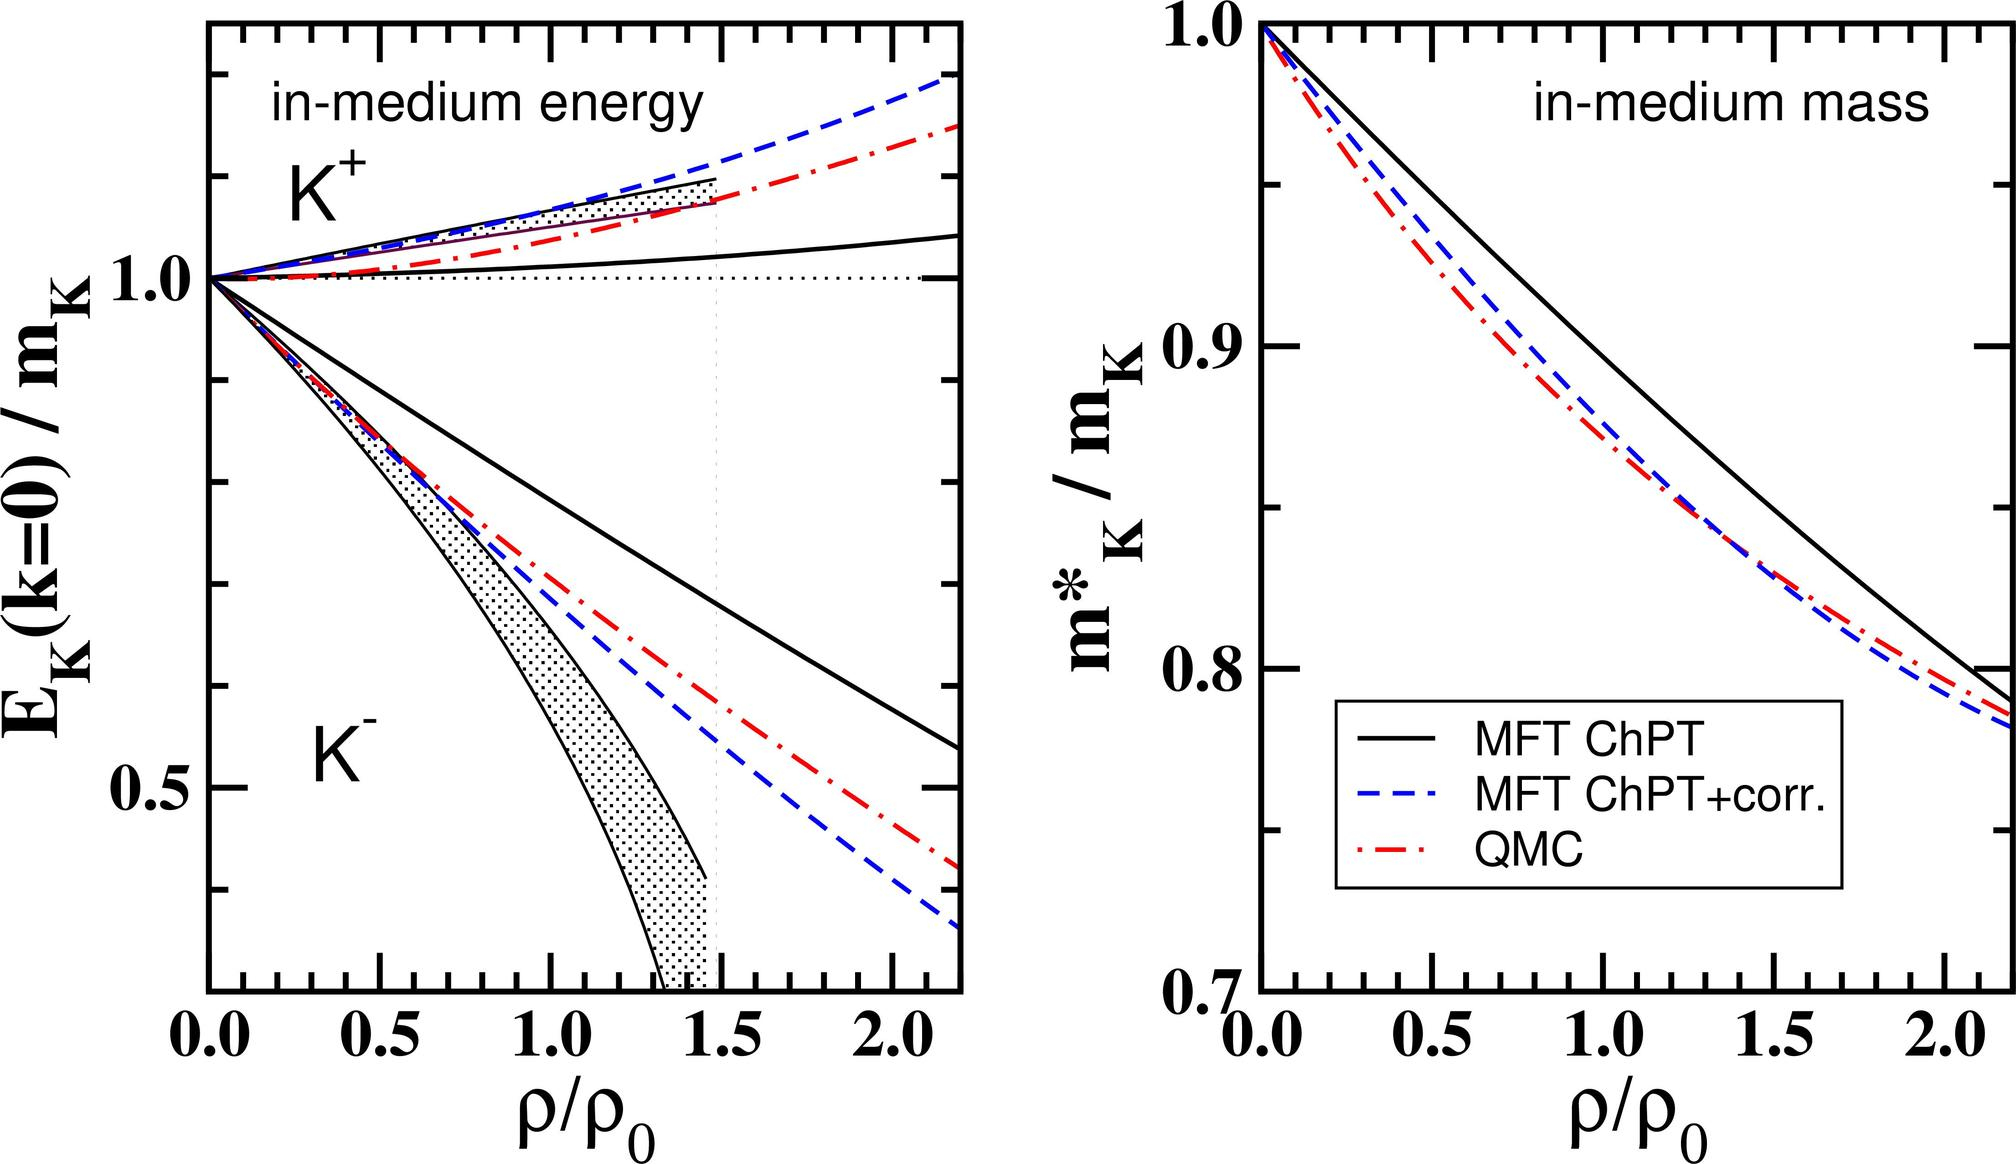What implications might these predictions have for understanding neutron star interiors? Theoretical predictions about the mass of \( K^+ \) mesons in different nuclear densities, as illustrated in the graph, are crucial for understanding the properties of neutron star interiors. Neutron stars, having extremely high nuclear density, can be better modeled with these predictions. Less decrease in the \( K^+ \) meson mass as per MFT ChPT suggests stiffer equations of state, potentially influencing the star's structure, such as its maximum mass and radius. Conversely, significant mass reductions as predicted by QMC could imply softer equations of state, affecting the star's stability and its gravitational wave signatures. These insights provide vital contributions to astrophysical models and understanding the extreme physical conditions present in such celestial objects. 